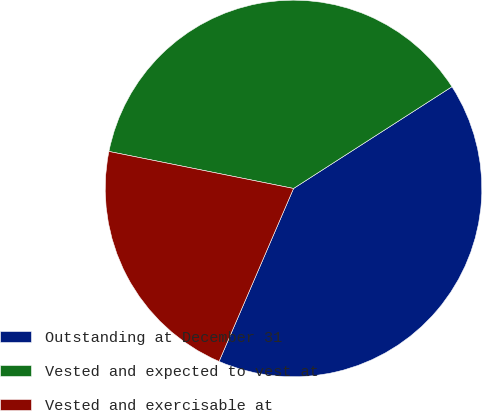<chart> <loc_0><loc_0><loc_500><loc_500><pie_chart><fcel>Outstanding at December 31<fcel>Vested and expected to vest at<fcel>Vested and exercisable at<nl><fcel>40.56%<fcel>37.76%<fcel>21.68%<nl></chart> 